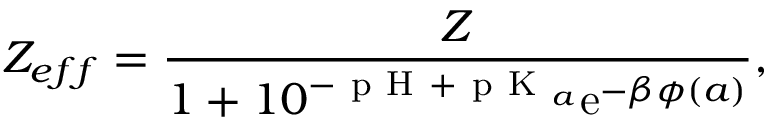Convert formula to latex. <formula><loc_0><loc_0><loc_500><loc_500>Z _ { e f f } = \frac { Z } { 1 + 1 0 ^ { - p H + p K _ { a } } e ^ { - \beta \phi ( a ) } } ,</formula> 